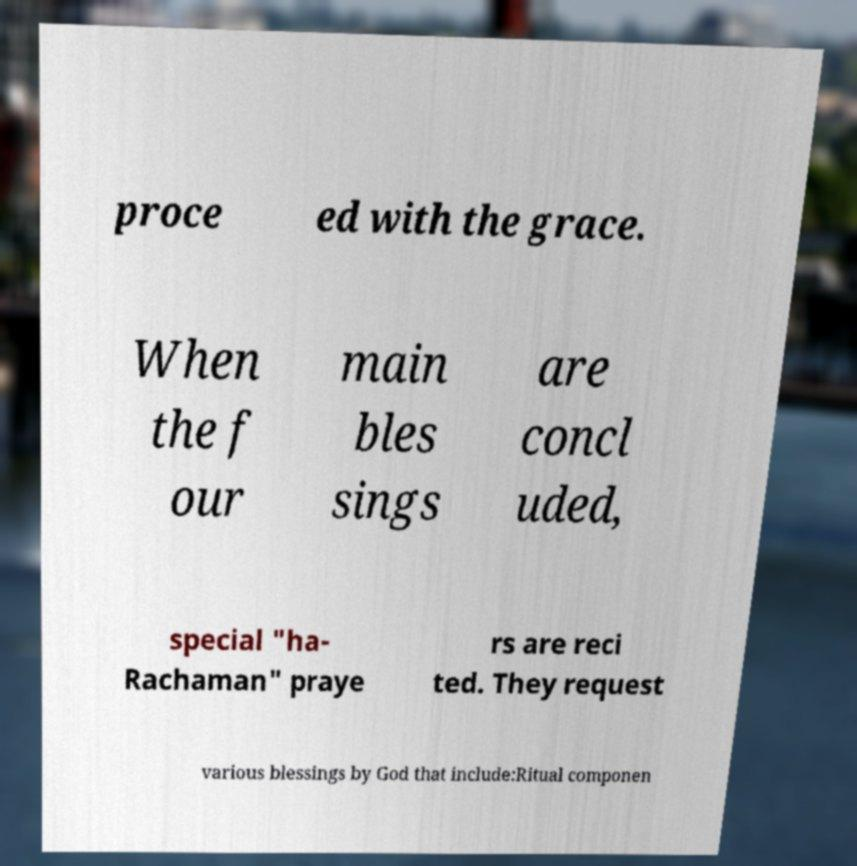Can you read and provide the text displayed in the image?This photo seems to have some interesting text. Can you extract and type it out for me? proce ed with the grace. When the f our main bles sings are concl uded, special "ha- Rachaman" praye rs are reci ted. They request various blessings by God that include:Ritual componen 